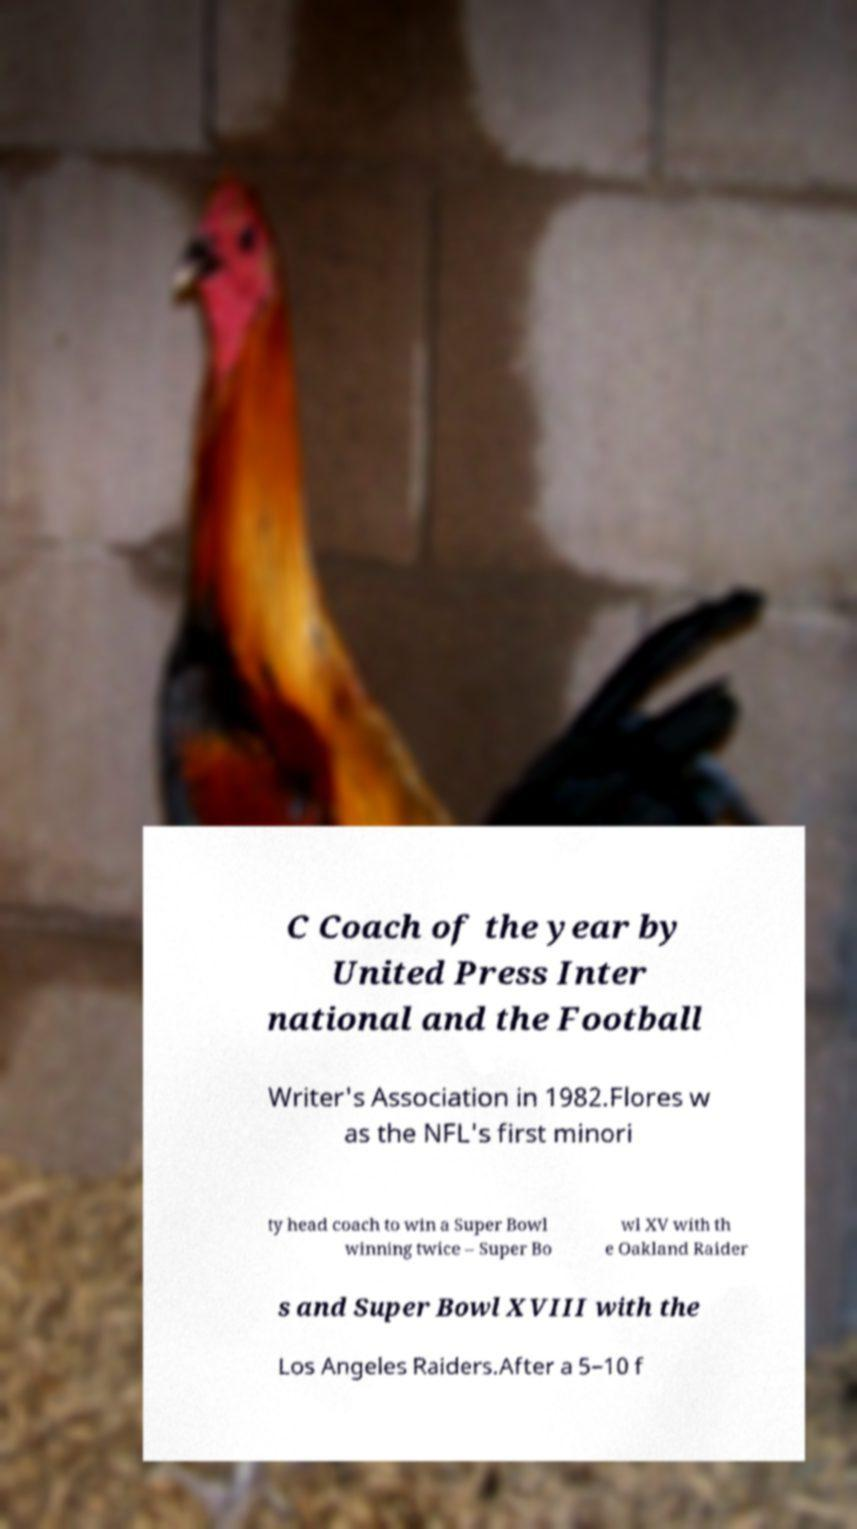Please identify and transcribe the text found in this image. C Coach of the year by United Press Inter national and the Football Writer's Association in 1982.Flores w as the NFL's first minori ty head coach to win a Super Bowl winning twice – Super Bo wl XV with th e Oakland Raider s and Super Bowl XVIII with the Los Angeles Raiders.After a 5–10 f 